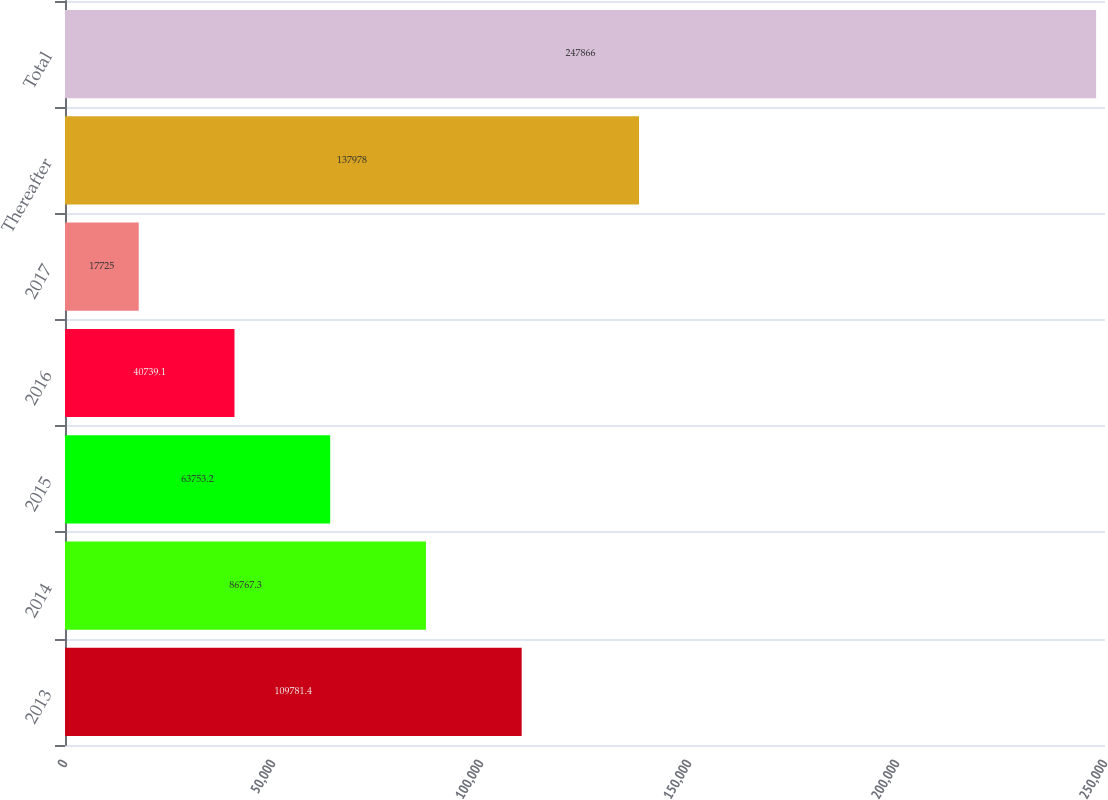<chart> <loc_0><loc_0><loc_500><loc_500><bar_chart><fcel>2013<fcel>2014<fcel>2015<fcel>2016<fcel>2017<fcel>Thereafter<fcel>Total<nl><fcel>109781<fcel>86767.3<fcel>63753.2<fcel>40739.1<fcel>17725<fcel>137978<fcel>247866<nl></chart> 